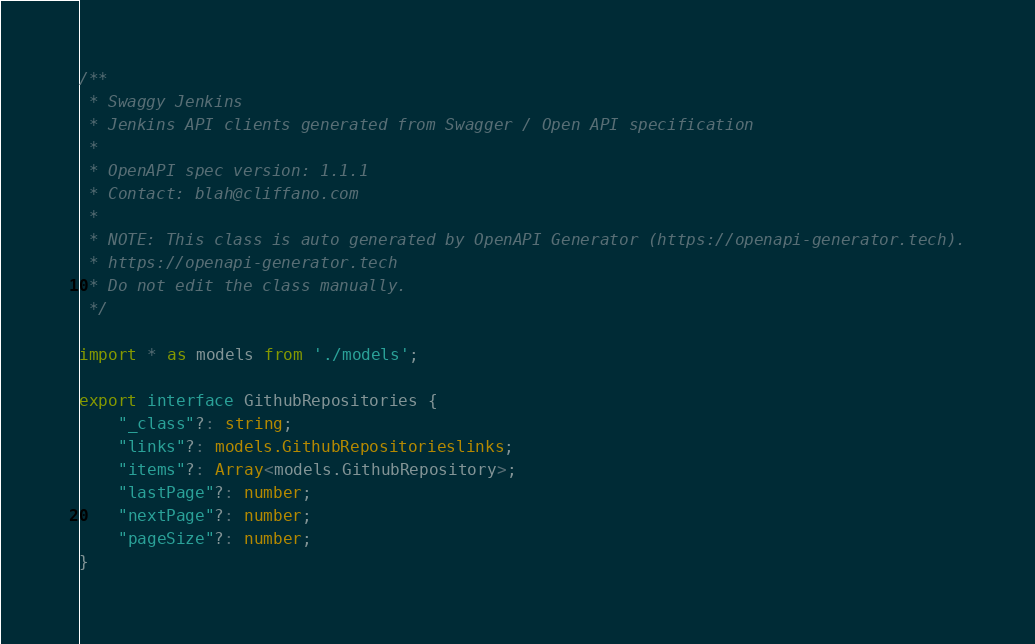Convert code to text. <code><loc_0><loc_0><loc_500><loc_500><_TypeScript_>/**
 * Swaggy Jenkins
 * Jenkins API clients generated from Swagger / Open API specification
 *
 * OpenAPI spec version: 1.1.1
 * Contact: blah@cliffano.com
 *
 * NOTE: This class is auto generated by OpenAPI Generator (https://openapi-generator.tech).
 * https://openapi-generator.tech
 * Do not edit the class manually.
 */

import * as models from './models';

export interface GithubRepositories {
    "_class"?: string;
    "links"?: models.GithubRepositorieslinks;
    "items"?: Array<models.GithubRepository>;
    "lastPage"?: number;
    "nextPage"?: number;
    "pageSize"?: number;
}

</code> 